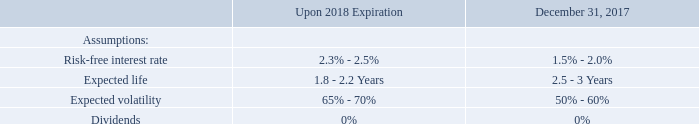DERIVATIVE LIABILITIES
In connection with the issuance of Series A-1 Preferred Stock in June 2017, the Company issued a warrant with variable consideration through September 2018. The Company determined that this instrument is an embedded derivative pursuant to ASC 815, “Derivatives and Hedging.” The accounting treatment of derivative financial instruments requires that the Company record the warrant, at its fair value as of the inception date of the agreement and at fair value as of each subsequent balance sheet date through the expiration of the variable consideration. Any change in fair value is recorded as a change in the fair value of derivative liabilities for each reporting period at each balance sheet date. The Company reassesses the classification at each balance sheet date. If the classification changes as a result of events during the period, the contract is reclassified as of the date of the event that caused the reclassification. On September 19, 2018, upon expiration of the variable consideration, the warrant liability of $4.5 million was reclassified to equity.
The Monte Carlo Valuation model is used to estimate the fair value of the warrant. The model was developed for use in estimating the fair value of traded options or warrants. The expected volatility is estimated based on the most recent historical period of time equal to the weighted average life of the instrument granted.
The risk-free interest rate used is the United States Treasury rate for the day of the grant having a term equal to the life of the equity instrument. The volatility is a measure of the amount by which the Company’s share price has fluctuated or is expected to fluctuate. The dividend yield is zero as the Company has not made any dividend payment and has no plans to pay dividends in the foreseeable future. The Company determines the expected term of its warrant awards by using the contractual term.
The principal assumptions used in applying the model were as follows:
What is the expected life upon 2018 expiration? 1.8 - 2.2 years. What is the expected life as at December 31, 2017? 2.5 - 3 years. What is the percentage dividends of the derivative liabilities? 0%. What is the average expected life upon 2018 expiration? (1.8 + 2.2)/2 
Answer: 2. What is the average expected life as at December 31, 2017? (2.5 + 3)/2 
Answer: 2.75. What is the average expected volatility of derivative liabilities due on December 31, 2017?
Answer scale should be: percent. ( 50 + 60)/2 
Answer: 55. 